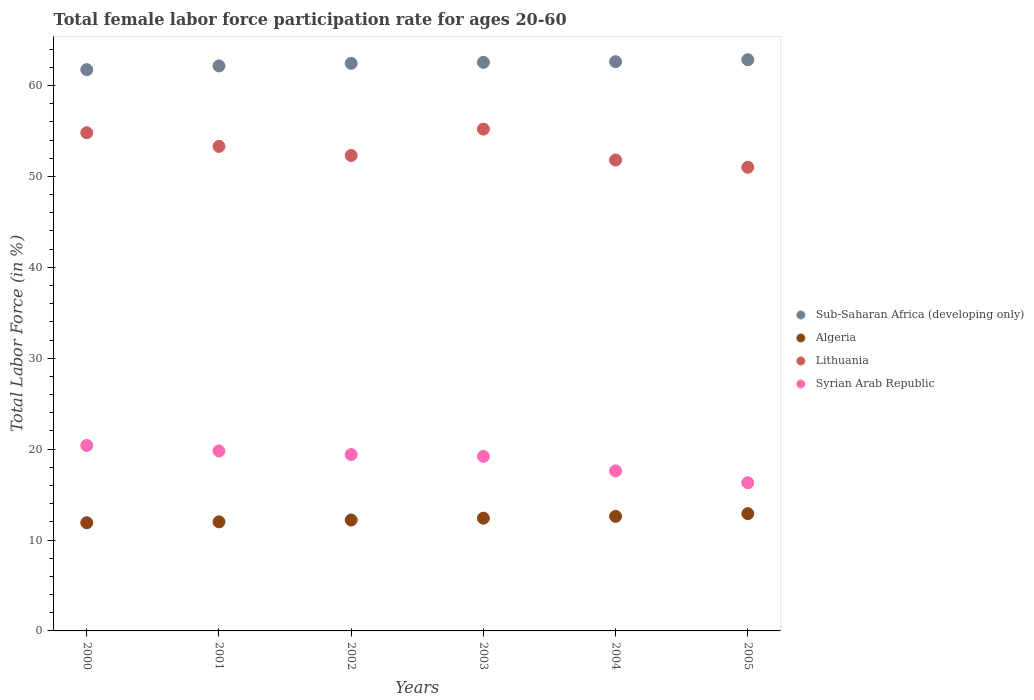Is the number of dotlines equal to the number of legend labels?
Offer a very short reply. Yes. What is the female labor force participation rate in Sub-Saharan Africa (developing only) in 2004?
Your answer should be very brief. 62.62. Across all years, what is the maximum female labor force participation rate in Algeria?
Give a very brief answer. 12.9. Across all years, what is the minimum female labor force participation rate in Sub-Saharan Africa (developing only)?
Your answer should be compact. 61.74. In which year was the female labor force participation rate in Syrian Arab Republic maximum?
Ensure brevity in your answer.  2000. What is the total female labor force participation rate in Sub-Saharan Africa (developing only) in the graph?
Provide a short and direct response. 374.32. What is the difference between the female labor force participation rate in Lithuania in 2000 and that in 2005?
Provide a short and direct response. 3.8. What is the difference between the female labor force participation rate in Syrian Arab Republic in 2004 and the female labor force participation rate in Algeria in 2001?
Provide a succinct answer. 5.6. What is the average female labor force participation rate in Lithuania per year?
Give a very brief answer. 53.07. In the year 2004, what is the difference between the female labor force participation rate in Sub-Saharan Africa (developing only) and female labor force participation rate in Syrian Arab Republic?
Offer a terse response. 45.02. In how many years, is the female labor force participation rate in Sub-Saharan Africa (developing only) greater than 34 %?
Offer a terse response. 6. What is the ratio of the female labor force participation rate in Lithuania in 2002 to that in 2004?
Ensure brevity in your answer.  1.01. What is the difference between the highest and the second highest female labor force participation rate in Sub-Saharan Africa (developing only)?
Keep it short and to the point. 0.22. What is the difference between the highest and the lowest female labor force participation rate in Lithuania?
Offer a very short reply. 4.2. In how many years, is the female labor force participation rate in Syrian Arab Republic greater than the average female labor force participation rate in Syrian Arab Republic taken over all years?
Your answer should be very brief. 4. Is it the case that in every year, the sum of the female labor force participation rate in Syrian Arab Republic and female labor force participation rate in Sub-Saharan Africa (developing only)  is greater than the sum of female labor force participation rate in Lithuania and female labor force participation rate in Algeria?
Provide a short and direct response. Yes. Is it the case that in every year, the sum of the female labor force participation rate in Syrian Arab Republic and female labor force participation rate in Algeria  is greater than the female labor force participation rate in Lithuania?
Offer a terse response. No. Does the female labor force participation rate in Lithuania monotonically increase over the years?
Offer a very short reply. No. Is the female labor force participation rate in Syrian Arab Republic strictly greater than the female labor force participation rate in Lithuania over the years?
Your answer should be compact. No. Is the female labor force participation rate in Sub-Saharan Africa (developing only) strictly less than the female labor force participation rate in Algeria over the years?
Offer a terse response. No. How many dotlines are there?
Keep it short and to the point. 4. How many years are there in the graph?
Provide a succinct answer. 6. Are the values on the major ticks of Y-axis written in scientific E-notation?
Your answer should be compact. No. Does the graph contain any zero values?
Make the answer very short. No. Does the graph contain grids?
Make the answer very short. No. Where does the legend appear in the graph?
Your response must be concise. Center right. How are the legend labels stacked?
Offer a very short reply. Vertical. What is the title of the graph?
Your answer should be very brief. Total female labor force participation rate for ages 20-60. What is the label or title of the X-axis?
Ensure brevity in your answer.  Years. What is the Total Labor Force (in %) in Sub-Saharan Africa (developing only) in 2000?
Keep it short and to the point. 61.74. What is the Total Labor Force (in %) of Algeria in 2000?
Give a very brief answer. 11.9. What is the Total Labor Force (in %) in Lithuania in 2000?
Ensure brevity in your answer.  54.8. What is the Total Labor Force (in %) in Syrian Arab Republic in 2000?
Provide a succinct answer. 20.4. What is the Total Labor Force (in %) of Sub-Saharan Africa (developing only) in 2001?
Ensure brevity in your answer.  62.15. What is the Total Labor Force (in %) in Lithuania in 2001?
Provide a succinct answer. 53.3. What is the Total Labor Force (in %) in Syrian Arab Republic in 2001?
Give a very brief answer. 19.8. What is the Total Labor Force (in %) of Sub-Saharan Africa (developing only) in 2002?
Ensure brevity in your answer.  62.44. What is the Total Labor Force (in %) of Algeria in 2002?
Provide a succinct answer. 12.2. What is the Total Labor Force (in %) of Lithuania in 2002?
Your answer should be very brief. 52.3. What is the Total Labor Force (in %) in Syrian Arab Republic in 2002?
Make the answer very short. 19.4. What is the Total Labor Force (in %) in Sub-Saharan Africa (developing only) in 2003?
Provide a succinct answer. 62.54. What is the Total Labor Force (in %) in Algeria in 2003?
Offer a terse response. 12.4. What is the Total Labor Force (in %) of Lithuania in 2003?
Your answer should be very brief. 55.2. What is the Total Labor Force (in %) of Syrian Arab Republic in 2003?
Your answer should be very brief. 19.2. What is the Total Labor Force (in %) of Sub-Saharan Africa (developing only) in 2004?
Keep it short and to the point. 62.62. What is the Total Labor Force (in %) of Algeria in 2004?
Provide a short and direct response. 12.6. What is the Total Labor Force (in %) of Lithuania in 2004?
Keep it short and to the point. 51.8. What is the Total Labor Force (in %) in Syrian Arab Republic in 2004?
Give a very brief answer. 17.6. What is the Total Labor Force (in %) of Sub-Saharan Africa (developing only) in 2005?
Offer a terse response. 62.83. What is the Total Labor Force (in %) of Algeria in 2005?
Your response must be concise. 12.9. What is the Total Labor Force (in %) in Syrian Arab Republic in 2005?
Offer a terse response. 16.3. Across all years, what is the maximum Total Labor Force (in %) in Sub-Saharan Africa (developing only)?
Your response must be concise. 62.83. Across all years, what is the maximum Total Labor Force (in %) in Algeria?
Your answer should be compact. 12.9. Across all years, what is the maximum Total Labor Force (in %) of Lithuania?
Make the answer very short. 55.2. Across all years, what is the maximum Total Labor Force (in %) of Syrian Arab Republic?
Ensure brevity in your answer.  20.4. Across all years, what is the minimum Total Labor Force (in %) in Sub-Saharan Africa (developing only)?
Give a very brief answer. 61.74. Across all years, what is the minimum Total Labor Force (in %) of Algeria?
Your answer should be very brief. 11.9. Across all years, what is the minimum Total Labor Force (in %) in Syrian Arab Republic?
Your answer should be compact. 16.3. What is the total Total Labor Force (in %) of Sub-Saharan Africa (developing only) in the graph?
Offer a terse response. 374.32. What is the total Total Labor Force (in %) of Lithuania in the graph?
Give a very brief answer. 318.4. What is the total Total Labor Force (in %) of Syrian Arab Republic in the graph?
Keep it short and to the point. 112.7. What is the difference between the Total Labor Force (in %) of Sub-Saharan Africa (developing only) in 2000 and that in 2001?
Make the answer very short. -0.41. What is the difference between the Total Labor Force (in %) of Sub-Saharan Africa (developing only) in 2000 and that in 2002?
Your answer should be compact. -0.7. What is the difference between the Total Labor Force (in %) in Algeria in 2000 and that in 2002?
Offer a terse response. -0.3. What is the difference between the Total Labor Force (in %) in Lithuania in 2000 and that in 2002?
Keep it short and to the point. 2.5. What is the difference between the Total Labor Force (in %) of Syrian Arab Republic in 2000 and that in 2002?
Your response must be concise. 1. What is the difference between the Total Labor Force (in %) in Sub-Saharan Africa (developing only) in 2000 and that in 2003?
Give a very brief answer. -0.8. What is the difference between the Total Labor Force (in %) in Algeria in 2000 and that in 2003?
Provide a short and direct response. -0.5. What is the difference between the Total Labor Force (in %) in Syrian Arab Republic in 2000 and that in 2003?
Make the answer very short. 1.2. What is the difference between the Total Labor Force (in %) of Sub-Saharan Africa (developing only) in 2000 and that in 2004?
Your answer should be very brief. -0.88. What is the difference between the Total Labor Force (in %) of Algeria in 2000 and that in 2004?
Offer a terse response. -0.7. What is the difference between the Total Labor Force (in %) of Lithuania in 2000 and that in 2004?
Provide a short and direct response. 3. What is the difference between the Total Labor Force (in %) in Sub-Saharan Africa (developing only) in 2000 and that in 2005?
Provide a short and direct response. -1.09. What is the difference between the Total Labor Force (in %) in Algeria in 2000 and that in 2005?
Your response must be concise. -1. What is the difference between the Total Labor Force (in %) in Sub-Saharan Africa (developing only) in 2001 and that in 2002?
Provide a succinct answer. -0.28. What is the difference between the Total Labor Force (in %) in Sub-Saharan Africa (developing only) in 2001 and that in 2003?
Provide a succinct answer. -0.39. What is the difference between the Total Labor Force (in %) of Lithuania in 2001 and that in 2003?
Provide a succinct answer. -1.9. What is the difference between the Total Labor Force (in %) of Sub-Saharan Africa (developing only) in 2001 and that in 2004?
Offer a very short reply. -0.47. What is the difference between the Total Labor Force (in %) in Lithuania in 2001 and that in 2004?
Provide a short and direct response. 1.5. What is the difference between the Total Labor Force (in %) of Sub-Saharan Africa (developing only) in 2001 and that in 2005?
Your response must be concise. -0.68. What is the difference between the Total Labor Force (in %) of Algeria in 2001 and that in 2005?
Offer a very short reply. -0.9. What is the difference between the Total Labor Force (in %) of Sub-Saharan Africa (developing only) in 2002 and that in 2003?
Your answer should be very brief. -0.11. What is the difference between the Total Labor Force (in %) of Lithuania in 2002 and that in 2003?
Keep it short and to the point. -2.9. What is the difference between the Total Labor Force (in %) in Sub-Saharan Africa (developing only) in 2002 and that in 2004?
Offer a very short reply. -0.18. What is the difference between the Total Labor Force (in %) in Algeria in 2002 and that in 2004?
Your answer should be very brief. -0.4. What is the difference between the Total Labor Force (in %) in Syrian Arab Republic in 2002 and that in 2004?
Provide a short and direct response. 1.8. What is the difference between the Total Labor Force (in %) of Sub-Saharan Africa (developing only) in 2002 and that in 2005?
Your response must be concise. -0.4. What is the difference between the Total Labor Force (in %) of Lithuania in 2002 and that in 2005?
Provide a succinct answer. 1.3. What is the difference between the Total Labor Force (in %) of Syrian Arab Republic in 2002 and that in 2005?
Keep it short and to the point. 3.1. What is the difference between the Total Labor Force (in %) of Sub-Saharan Africa (developing only) in 2003 and that in 2004?
Make the answer very short. -0.07. What is the difference between the Total Labor Force (in %) in Syrian Arab Republic in 2003 and that in 2004?
Your answer should be very brief. 1.6. What is the difference between the Total Labor Force (in %) in Sub-Saharan Africa (developing only) in 2003 and that in 2005?
Ensure brevity in your answer.  -0.29. What is the difference between the Total Labor Force (in %) of Algeria in 2003 and that in 2005?
Provide a short and direct response. -0.5. What is the difference between the Total Labor Force (in %) of Lithuania in 2003 and that in 2005?
Ensure brevity in your answer.  4.2. What is the difference between the Total Labor Force (in %) in Syrian Arab Republic in 2003 and that in 2005?
Provide a short and direct response. 2.9. What is the difference between the Total Labor Force (in %) of Sub-Saharan Africa (developing only) in 2004 and that in 2005?
Your answer should be very brief. -0.22. What is the difference between the Total Labor Force (in %) in Sub-Saharan Africa (developing only) in 2000 and the Total Labor Force (in %) in Algeria in 2001?
Provide a succinct answer. 49.74. What is the difference between the Total Labor Force (in %) of Sub-Saharan Africa (developing only) in 2000 and the Total Labor Force (in %) of Lithuania in 2001?
Make the answer very short. 8.44. What is the difference between the Total Labor Force (in %) in Sub-Saharan Africa (developing only) in 2000 and the Total Labor Force (in %) in Syrian Arab Republic in 2001?
Your answer should be very brief. 41.94. What is the difference between the Total Labor Force (in %) in Algeria in 2000 and the Total Labor Force (in %) in Lithuania in 2001?
Your answer should be very brief. -41.4. What is the difference between the Total Labor Force (in %) of Algeria in 2000 and the Total Labor Force (in %) of Syrian Arab Republic in 2001?
Offer a very short reply. -7.9. What is the difference between the Total Labor Force (in %) of Sub-Saharan Africa (developing only) in 2000 and the Total Labor Force (in %) of Algeria in 2002?
Provide a succinct answer. 49.54. What is the difference between the Total Labor Force (in %) in Sub-Saharan Africa (developing only) in 2000 and the Total Labor Force (in %) in Lithuania in 2002?
Make the answer very short. 9.44. What is the difference between the Total Labor Force (in %) of Sub-Saharan Africa (developing only) in 2000 and the Total Labor Force (in %) of Syrian Arab Republic in 2002?
Provide a short and direct response. 42.34. What is the difference between the Total Labor Force (in %) in Algeria in 2000 and the Total Labor Force (in %) in Lithuania in 2002?
Keep it short and to the point. -40.4. What is the difference between the Total Labor Force (in %) of Lithuania in 2000 and the Total Labor Force (in %) of Syrian Arab Republic in 2002?
Offer a very short reply. 35.4. What is the difference between the Total Labor Force (in %) in Sub-Saharan Africa (developing only) in 2000 and the Total Labor Force (in %) in Algeria in 2003?
Your answer should be compact. 49.34. What is the difference between the Total Labor Force (in %) in Sub-Saharan Africa (developing only) in 2000 and the Total Labor Force (in %) in Lithuania in 2003?
Give a very brief answer. 6.54. What is the difference between the Total Labor Force (in %) of Sub-Saharan Africa (developing only) in 2000 and the Total Labor Force (in %) of Syrian Arab Republic in 2003?
Provide a short and direct response. 42.54. What is the difference between the Total Labor Force (in %) in Algeria in 2000 and the Total Labor Force (in %) in Lithuania in 2003?
Ensure brevity in your answer.  -43.3. What is the difference between the Total Labor Force (in %) of Lithuania in 2000 and the Total Labor Force (in %) of Syrian Arab Republic in 2003?
Offer a terse response. 35.6. What is the difference between the Total Labor Force (in %) of Sub-Saharan Africa (developing only) in 2000 and the Total Labor Force (in %) of Algeria in 2004?
Your answer should be very brief. 49.14. What is the difference between the Total Labor Force (in %) in Sub-Saharan Africa (developing only) in 2000 and the Total Labor Force (in %) in Lithuania in 2004?
Make the answer very short. 9.94. What is the difference between the Total Labor Force (in %) in Sub-Saharan Africa (developing only) in 2000 and the Total Labor Force (in %) in Syrian Arab Republic in 2004?
Your answer should be compact. 44.14. What is the difference between the Total Labor Force (in %) in Algeria in 2000 and the Total Labor Force (in %) in Lithuania in 2004?
Your answer should be compact. -39.9. What is the difference between the Total Labor Force (in %) in Lithuania in 2000 and the Total Labor Force (in %) in Syrian Arab Republic in 2004?
Your answer should be compact. 37.2. What is the difference between the Total Labor Force (in %) in Sub-Saharan Africa (developing only) in 2000 and the Total Labor Force (in %) in Algeria in 2005?
Your answer should be very brief. 48.84. What is the difference between the Total Labor Force (in %) of Sub-Saharan Africa (developing only) in 2000 and the Total Labor Force (in %) of Lithuania in 2005?
Provide a short and direct response. 10.74. What is the difference between the Total Labor Force (in %) of Sub-Saharan Africa (developing only) in 2000 and the Total Labor Force (in %) of Syrian Arab Republic in 2005?
Your response must be concise. 45.44. What is the difference between the Total Labor Force (in %) in Algeria in 2000 and the Total Labor Force (in %) in Lithuania in 2005?
Your answer should be very brief. -39.1. What is the difference between the Total Labor Force (in %) of Algeria in 2000 and the Total Labor Force (in %) of Syrian Arab Republic in 2005?
Offer a very short reply. -4.4. What is the difference between the Total Labor Force (in %) in Lithuania in 2000 and the Total Labor Force (in %) in Syrian Arab Republic in 2005?
Provide a short and direct response. 38.5. What is the difference between the Total Labor Force (in %) in Sub-Saharan Africa (developing only) in 2001 and the Total Labor Force (in %) in Algeria in 2002?
Offer a terse response. 49.95. What is the difference between the Total Labor Force (in %) of Sub-Saharan Africa (developing only) in 2001 and the Total Labor Force (in %) of Lithuania in 2002?
Make the answer very short. 9.85. What is the difference between the Total Labor Force (in %) in Sub-Saharan Africa (developing only) in 2001 and the Total Labor Force (in %) in Syrian Arab Republic in 2002?
Give a very brief answer. 42.75. What is the difference between the Total Labor Force (in %) of Algeria in 2001 and the Total Labor Force (in %) of Lithuania in 2002?
Offer a very short reply. -40.3. What is the difference between the Total Labor Force (in %) in Algeria in 2001 and the Total Labor Force (in %) in Syrian Arab Republic in 2002?
Offer a very short reply. -7.4. What is the difference between the Total Labor Force (in %) of Lithuania in 2001 and the Total Labor Force (in %) of Syrian Arab Republic in 2002?
Your response must be concise. 33.9. What is the difference between the Total Labor Force (in %) in Sub-Saharan Africa (developing only) in 2001 and the Total Labor Force (in %) in Algeria in 2003?
Provide a short and direct response. 49.75. What is the difference between the Total Labor Force (in %) in Sub-Saharan Africa (developing only) in 2001 and the Total Labor Force (in %) in Lithuania in 2003?
Offer a very short reply. 6.95. What is the difference between the Total Labor Force (in %) in Sub-Saharan Africa (developing only) in 2001 and the Total Labor Force (in %) in Syrian Arab Republic in 2003?
Keep it short and to the point. 42.95. What is the difference between the Total Labor Force (in %) of Algeria in 2001 and the Total Labor Force (in %) of Lithuania in 2003?
Offer a very short reply. -43.2. What is the difference between the Total Labor Force (in %) in Algeria in 2001 and the Total Labor Force (in %) in Syrian Arab Republic in 2003?
Your response must be concise. -7.2. What is the difference between the Total Labor Force (in %) in Lithuania in 2001 and the Total Labor Force (in %) in Syrian Arab Republic in 2003?
Ensure brevity in your answer.  34.1. What is the difference between the Total Labor Force (in %) in Sub-Saharan Africa (developing only) in 2001 and the Total Labor Force (in %) in Algeria in 2004?
Your answer should be compact. 49.55. What is the difference between the Total Labor Force (in %) of Sub-Saharan Africa (developing only) in 2001 and the Total Labor Force (in %) of Lithuania in 2004?
Give a very brief answer. 10.35. What is the difference between the Total Labor Force (in %) of Sub-Saharan Africa (developing only) in 2001 and the Total Labor Force (in %) of Syrian Arab Republic in 2004?
Offer a very short reply. 44.55. What is the difference between the Total Labor Force (in %) of Algeria in 2001 and the Total Labor Force (in %) of Lithuania in 2004?
Your answer should be compact. -39.8. What is the difference between the Total Labor Force (in %) in Lithuania in 2001 and the Total Labor Force (in %) in Syrian Arab Republic in 2004?
Keep it short and to the point. 35.7. What is the difference between the Total Labor Force (in %) of Sub-Saharan Africa (developing only) in 2001 and the Total Labor Force (in %) of Algeria in 2005?
Your answer should be compact. 49.25. What is the difference between the Total Labor Force (in %) of Sub-Saharan Africa (developing only) in 2001 and the Total Labor Force (in %) of Lithuania in 2005?
Provide a short and direct response. 11.15. What is the difference between the Total Labor Force (in %) in Sub-Saharan Africa (developing only) in 2001 and the Total Labor Force (in %) in Syrian Arab Republic in 2005?
Your answer should be compact. 45.85. What is the difference between the Total Labor Force (in %) of Algeria in 2001 and the Total Labor Force (in %) of Lithuania in 2005?
Your answer should be very brief. -39. What is the difference between the Total Labor Force (in %) of Sub-Saharan Africa (developing only) in 2002 and the Total Labor Force (in %) of Algeria in 2003?
Your answer should be compact. 50.04. What is the difference between the Total Labor Force (in %) in Sub-Saharan Africa (developing only) in 2002 and the Total Labor Force (in %) in Lithuania in 2003?
Your response must be concise. 7.24. What is the difference between the Total Labor Force (in %) in Sub-Saharan Africa (developing only) in 2002 and the Total Labor Force (in %) in Syrian Arab Republic in 2003?
Ensure brevity in your answer.  43.24. What is the difference between the Total Labor Force (in %) in Algeria in 2002 and the Total Labor Force (in %) in Lithuania in 2003?
Ensure brevity in your answer.  -43. What is the difference between the Total Labor Force (in %) in Lithuania in 2002 and the Total Labor Force (in %) in Syrian Arab Republic in 2003?
Your answer should be very brief. 33.1. What is the difference between the Total Labor Force (in %) of Sub-Saharan Africa (developing only) in 2002 and the Total Labor Force (in %) of Algeria in 2004?
Your answer should be very brief. 49.84. What is the difference between the Total Labor Force (in %) of Sub-Saharan Africa (developing only) in 2002 and the Total Labor Force (in %) of Lithuania in 2004?
Give a very brief answer. 10.64. What is the difference between the Total Labor Force (in %) in Sub-Saharan Africa (developing only) in 2002 and the Total Labor Force (in %) in Syrian Arab Republic in 2004?
Offer a terse response. 44.84. What is the difference between the Total Labor Force (in %) in Algeria in 2002 and the Total Labor Force (in %) in Lithuania in 2004?
Provide a succinct answer. -39.6. What is the difference between the Total Labor Force (in %) in Lithuania in 2002 and the Total Labor Force (in %) in Syrian Arab Republic in 2004?
Ensure brevity in your answer.  34.7. What is the difference between the Total Labor Force (in %) of Sub-Saharan Africa (developing only) in 2002 and the Total Labor Force (in %) of Algeria in 2005?
Give a very brief answer. 49.54. What is the difference between the Total Labor Force (in %) of Sub-Saharan Africa (developing only) in 2002 and the Total Labor Force (in %) of Lithuania in 2005?
Provide a short and direct response. 11.44. What is the difference between the Total Labor Force (in %) in Sub-Saharan Africa (developing only) in 2002 and the Total Labor Force (in %) in Syrian Arab Republic in 2005?
Offer a terse response. 46.14. What is the difference between the Total Labor Force (in %) in Algeria in 2002 and the Total Labor Force (in %) in Lithuania in 2005?
Keep it short and to the point. -38.8. What is the difference between the Total Labor Force (in %) in Lithuania in 2002 and the Total Labor Force (in %) in Syrian Arab Republic in 2005?
Give a very brief answer. 36. What is the difference between the Total Labor Force (in %) in Sub-Saharan Africa (developing only) in 2003 and the Total Labor Force (in %) in Algeria in 2004?
Keep it short and to the point. 49.94. What is the difference between the Total Labor Force (in %) of Sub-Saharan Africa (developing only) in 2003 and the Total Labor Force (in %) of Lithuania in 2004?
Provide a short and direct response. 10.74. What is the difference between the Total Labor Force (in %) in Sub-Saharan Africa (developing only) in 2003 and the Total Labor Force (in %) in Syrian Arab Republic in 2004?
Your answer should be compact. 44.94. What is the difference between the Total Labor Force (in %) in Algeria in 2003 and the Total Labor Force (in %) in Lithuania in 2004?
Your response must be concise. -39.4. What is the difference between the Total Labor Force (in %) of Lithuania in 2003 and the Total Labor Force (in %) of Syrian Arab Republic in 2004?
Ensure brevity in your answer.  37.6. What is the difference between the Total Labor Force (in %) of Sub-Saharan Africa (developing only) in 2003 and the Total Labor Force (in %) of Algeria in 2005?
Provide a succinct answer. 49.64. What is the difference between the Total Labor Force (in %) in Sub-Saharan Africa (developing only) in 2003 and the Total Labor Force (in %) in Lithuania in 2005?
Keep it short and to the point. 11.54. What is the difference between the Total Labor Force (in %) of Sub-Saharan Africa (developing only) in 2003 and the Total Labor Force (in %) of Syrian Arab Republic in 2005?
Ensure brevity in your answer.  46.24. What is the difference between the Total Labor Force (in %) in Algeria in 2003 and the Total Labor Force (in %) in Lithuania in 2005?
Your response must be concise. -38.6. What is the difference between the Total Labor Force (in %) in Algeria in 2003 and the Total Labor Force (in %) in Syrian Arab Republic in 2005?
Ensure brevity in your answer.  -3.9. What is the difference between the Total Labor Force (in %) in Lithuania in 2003 and the Total Labor Force (in %) in Syrian Arab Republic in 2005?
Your answer should be compact. 38.9. What is the difference between the Total Labor Force (in %) in Sub-Saharan Africa (developing only) in 2004 and the Total Labor Force (in %) in Algeria in 2005?
Offer a terse response. 49.72. What is the difference between the Total Labor Force (in %) of Sub-Saharan Africa (developing only) in 2004 and the Total Labor Force (in %) of Lithuania in 2005?
Offer a very short reply. 11.62. What is the difference between the Total Labor Force (in %) of Sub-Saharan Africa (developing only) in 2004 and the Total Labor Force (in %) of Syrian Arab Republic in 2005?
Make the answer very short. 46.32. What is the difference between the Total Labor Force (in %) in Algeria in 2004 and the Total Labor Force (in %) in Lithuania in 2005?
Your answer should be very brief. -38.4. What is the difference between the Total Labor Force (in %) of Algeria in 2004 and the Total Labor Force (in %) of Syrian Arab Republic in 2005?
Offer a very short reply. -3.7. What is the difference between the Total Labor Force (in %) in Lithuania in 2004 and the Total Labor Force (in %) in Syrian Arab Republic in 2005?
Your answer should be compact. 35.5. What is the average Total Labor Force (in %) in Sub-Saharan Africa (developing only) per year?
Your answer should be very brief. 62.39. What is the average Total Labor Force (in %) in Algeria per year?
Ensure brevity in your answer.  12.33. What is the average Total Labor Force (in %) of Lithuania per year?
Offer a very short reply. 53.07. What is the average Total Labor Force (in %) of Syrian Arab Republic per year?
Provide a short and direct response. 18.78. In the year 2000, what is the difference between the Total Labor Force (in %) of Sub-Saharan Africa (developing only) and Total Labor Force (in %) of Algeria?
Ensure brevity in your answer.  49.84. In the year 2000, what is the difference between the Total Labor Force (in %) of Sub-Saharan Africa (developing only) and Total Labor Force (in %) of Lithuania?
Give a very brief answer. 6.94. In the year 2000, what is the difference between the Total Labor Force (in %) of Sub-Saharan Africa (developing only) and Total Labor Force (in %) of Syrian Arab Republic?
Your answer should be very brief. 41.34. In the year 2000, what is the difference between the Total Labor Force (in %) of Algeria and Total Labor Force (in %) of Lithuania?
Your answer should be compact. -42.9. In the year 2000, what is the difference between the Total Labor Force (in %) of Algeria and Total Labor Force (in %) of Syrian Arab Republic?
Your response must be concise. -8.5. In the year 2000, what is the difference between the Total Labor Force (in %) of Lithuania and Total Labor Force (in %) of Syrian Arab Republic?
Offer a very short reply. 34.4. In the year 2001, what is the difference between the Total Labor Force (in %) in Sub-Saharan Africa (developing only) and Total Labor Force (in %) in Algeria?
Offer a very short reply. 50.15. In the year 2001, what is the difference between the Total Labor Force (in %) of Sub-Saharan Africa (developing only) and Total Labor Force (in %) of Lithuania?
Keep it short and to the point. 8.85. In the year 2001, what is the difference between the Total Labor Force (in %) in Sub-Saharan Africa (developing only) and Total Labor Force (in %) in Syrian Arab Republic?
Ensure brevity in your answer.  42.35. In the year 2001, what is the difference between the Total Labor Force (in %) of Algeria and Total Labor Force (in %) of Lithuania?
Offer a terse response. -41.3. In the year 2001, what is the difference between the Total Labor Force (in %) of Lithuania and Total Labor Force (in %) of Syrian Arab Republic?
Provide a succinct answer. 33.5. In the year 2002, what is the difference between the Total Labor Force (in %) in Sub-Saharan Africa (developing only) and Total Labor Force (in %) in Algeria?
Make the answer very short. 50.24. In the year 2002, what is the difference between the Total Labor Force (in %) in Sub-Saharan Africa (developing only) and Total Labor Force (in %) in Lithuania?
Ensure brevity in your answer.  10.14. In the year 2002, what is the difference between the Total Labor Force (in %) in Sub-Saharan Africa (developing only) and Total Labor Force (in %) in Syrian Arab Republic?
Offer a terse response. 43.04. In the year 2002, what is the difference between the Total Labor Force (in %) of Algeria and Total Labor Force (in %) of Lithuania?
Keep it short and to the point. -40.1. In the year 2002, what is the difference between the Total Labor Force (in %) in Lithuania and Total Labor Force (in %) in Syrian Arab Republic?
Provide a succinct answer. 32.9. In the year 2003, what is the difference between the Total Labor Force (in %) of Sub-Saharan Africa (developing only) and Total Labor Force (in %) of Algeria?
Provide a short and direct response. 50.14. In the year 2003, what is the difference between the Total Labor Force (in %) of Sub-Saharan Africa (developing only) and Total Labor Force (in %) of Lithuania?
Offer a terse response. 7.34. In the year 2003, what is the difference between the Total Labor Force (in %) in Sub-Saharan Africa (developing only) and Total Labor Force (in %) in Syrian Arab Republic?
Give a very brief answer. 43.34. In the year 2003, what is the difference between the Total Labor Force (in %) of Algeria and Total Labor Force (in %) of Lithuania?
Your answer should be very brief. -42.8. In the year 2003, what is the difference between the Total Labor Force (in %) of Algeria and Total Labor Force (in %) of Syrian Arab Republic?
Ensure brevity in your answer.  -6.8. In the year 2003, what is the difference between the Total Labor Force (in %) of Lithuania and Total Labor Force (in %) of Syrian Arab Republic?
Ensure brevity in your answer.  36. In the year 2004, what is the difference between the Total Labor Force (in %) of Sub-Saharan Africa (developing only) and Total Labor Force (in %) of Algeria?
Give a very brief answer. 50.02. In the year 2004, what is the difference between the Total Labor Force (in %) in Sub-Saharan Africa (developing only) and Total Labor Force (in %) in Lithuania?
Provide a succinct answer. 10.82. In the year 2004, what is the difference between the Total Labor Force (in %) in Sub-Saharan Africa (developing only) and Total Labor Force (in %) in Syrian Arab Republic?
Ensure brevity in your answer.  45.02. In the year 2004, what is the difference between the Total Labor Force (in %) in Algeria and Total Labor Force (in %) in Lithuania?
Your answer should be compact. -39.2. In the year 2004, what is the difference between the Total Labor Force (in %) of Lithuania and Total Labor Force (in %) of Syrian Arab Republic?
Ensure brevity in your answer.  34.2. In the year 2005, what is the difference between the Total Labor Force (in %) of Sub-Saharan Africa (developing only) and Total Labor Force (in %) of Algeria?
Provide a succinct answer. 49.93. In the year 2005, what is the difference between the Total Labor Force (in %) in Sub-Saharan Africa (developing only) and Total Labor Force (in %) in Lithuania?
Your answer should be very brief. 11.83. In the year 2005, what is the difference between the Total Labor Force (in %) of Sub-Saharan Africa (developing only) and Total Labor Force (in %) of Syrian Arab Republic?
Make the answer very short. 46.53. In the year 2005, what is the difference between the Total Labor Force (in %) of Algeria and Total Labor Force (in %) of Lithuania?
Provide a short and direct response. -38.1. In the year 2005, what is the difference between the Total Labor Force (in %) of Algeria and Total Labor Force (in %) of Syrian Arab Republic?
Your answer should be compact. -3.4. In the year 2005, what is the difference between the Total Labor Force (in %) of Lithuania and Total Labor Force (in %) of Syrian Arab Republic?
Provide a short and direct response. 34.7. What is the ratio of the Total Labor Force (in %) of Algeria in 2000 to that in 2001?
Your response must be concise. 0.99. What is the ratio of the Total Labor Force (in %) of Lithuania in 2000 to that in 2001?
Ensure brevity in your answer.  1.03. What is the ratio of the Total Labor Force (in %) in Syrian Arab Republic in 2000 to that in 2001?
Provide a succinct answer. 1.03. What is the ratio of the Total Labor Force (in %) of Sub-Saharan Africa (developing only) in 2000 to that in 2002?
Offer a terse response. 0.99. What is the ratio of the Total Labor Force (in %) of Algeria in 2000 to that in 2002?
Provide a short and direct response. 0.98. What is the ratio of the Total Labor Force (in %) of Lithuania in 2000 to that in 2002?
Provide a short and direct response. 1.05. What is the ratio of the Total Labor Force (in %) in Syrian Arab Republic in 2000 to that in 2002?
Your response must be concise. 1.05. What is the ratio of the Total Labor Force (in %) of Sub-Saharan Africa (developing only) in 2000 to that in 2003?
Offer a terse response. 0.99. What is the ratio of the Total Labor Force (in %) of Algeria in 2000 to that in 2003?
Your response must be concise. 0.96. What is the ratio of the Total Labor Force (in %) of Syrian Arab Republic in 2000 to that in 2003?
Offer a very short reply. 1.06. What is the ratio of the Total Labor Force (in %) of Lithuania in 2000 to that in 2004?
Give a very brief answer. 1.06. What is the ratio of the Total Labor Force (in %) of Syrian Arab Republic in 2000 to that in 2004?
Ensure brevity in your answer.  1.16. What is the ratio of the Total Labor Force (in %) of Sub-Saharan Africa (developing only) in 2000 to that in 2005?
Your answer should be compact. 0.98. What is the ratio of the Total Labor Force (in %) in Algeria in 2000 to that in 2005?
Make the answer very short. 0.92. What is the ratio of the Total Labor Force (in %) in Lithuania in 2000 to that in 2005?
Keep it short and to the point. 1.07. What is the ratio of the Total Labor Force (in %) of Syrian Arab Republic in 2000 to that in 2005?
Keep it short and to the point. 1.25. What is the ratio of the Total Labor Force (in %) of Sub-Saharan Africa (developing only) in 2001 to that in 2002?
Your response must be concise. 1. What is the ratio of the Total Labor Force (in %) in Algeria in 2001 to that in 2002?
Give a very brief answer. 0.98. What is the ratio of the Total Labor Force (in %) in Lithuania in 2001 to that in 2002?
Provide a short and direct response. 1.02. What is the ratio of the Total Labor Force (in %) in Syrian Arab Republic in 2001 to that in 2002?
Give a very brief answer. 1.02. What is the ratio of the Total Labor Force (in %) of Lithuania in 2001 to that in 2003?
Provide a succinct answer. 0.97. What is the ratio of the Total Labor Force (in %) of Syrian Arab Republic in 2001 to that in 2003?
Give a very brief answer. 1.03. What is the ratio of the Total Labor Force (in %) in Algeria in 2001 to that in 2004?
Provide a short and direct response. 0.95. What is the ratio of the Total Labor Force (in %) of Sub-Saharan Africa (developing only) in 2001 to that in 2005?
Keep it short and to the point. 0.99. What is the ratio of the Total Labor Force (in %) in Algeria in 2001 to that in 2005?
Provide a short and direct response. 0.93. What is the ratio of the Total Labor Force (in %) in Lithuania in 2001 to that in 2005?
Provide a short and direct response. 1.05. What is the ratio of the Total Labor Force (in %) of Syrian Arab Republic in 2001 to that in 2005?
Offer a very short reply. 1.21. What is the ratio of the Total Labor Force (in %) of Sub-Saharan Africa (developing only) in 2002 to that in 2003?
Give a very brief answer. 1. What is the ratio of the Total Labor Force (in %) in Algeria in 2002 to that in 2003?
Provide a succinct answer. 0.98. What is the ratio of the Total Labor Force (in %) of Lithuania in 2002 to that in 2003?
Provide a short and direct response. 0.95. What is the ratio of the Total Labor Force (in %) of Syrian Arab Republic in 2002 to that in 2003?
Provide a short and direct response. 1.01. What is the ratio of the Total Labor Force (in %) in Algeria in 2002 to that in 2004?
Your answer should be very brief. 0.97. What is the ratio of the Total Labor Force (in %) of Lithuania in 2002 to that in 2004?
Offer a terse response. 1.01. What is the ratio of the Total Labor Force (in %) of Syrian Arab Republic in 2002 to that in 2004?
Your response must be concise. 1.1. What is the ratio of the Total Labor Force (in %) in Algeria in 2002 to that in 2005?
Provide a short and direct response. 0.95. What is the ratio of the Total Labor Force (in %) of Lithuania in 2002 to that in 2005?
Your answer should be very brief. 1.03. What is the ratio of the Total Labor Force (in %) in Syrian Arab Republic in 2002 to that in 2005?
Give a very brief answer. 1.19. What is the ratio of the Total Labor Force (in %) in Algeria in 2003 to that in 2004?
Make the answer very short. 0.98. What is the ratio of the Total Labor Force (in %) of Lithuania in 2003 to that in 2004?
Give a very brief answer. 1.07. What is the ratio of the Total Labor Force (in %) of Algeria in 2003 to that in 2005?
Make the answer very short. 0.96. What is the ratio of the Total Labor Force (in %) in Lithuania in 2003 to that in 2005?
Your answer should be compact. 1.08. What is the ratio of the Total Labor Force (in %) in Syrian Arab Republic in 2003 to that in 2005?
Your answer should be compact. 1.18. What is the ratio of the Total Labor Force (in %) in Sub-Saharan Africa (developing only) in 2004 to that in 2005?
Your answer should be very brief. 1. What is the ratio of the Total Labor Force (in %) in Algeria in 2004 to that in 2005?
Offer a terse response. 0.98. What is the ratio of the Total Labor Force (in %) in Lithuania in 2004 to that in 2005?
Provide a short and direct response. 1.02. What is the ratio of the Total Labor Force (in %) in Syrian Arab Republic in 2004 to that in 2005?
Provide a short and direct response. 1.08. What is the difference between the highest and the second highest Total Labor Force (in %) of Sub-Saharan Africa (developing only)?
Give a very brief answer. 0.22. What is the difference between the highest and the second highest Total Labor Force (in %) of Syrian Arab Republic?
Offer a very short reply. 0.6. What is the difference between the highest and the lowest Total Labor Force (in %) in Sub-Saharan Africa (developing only)?
Your answer should be compact. 1.09. What is the difference between the highest and the lowest Total Labor Force (in %) in Syrian Arab Republic?
Provide a short and direct response. 4.1. 